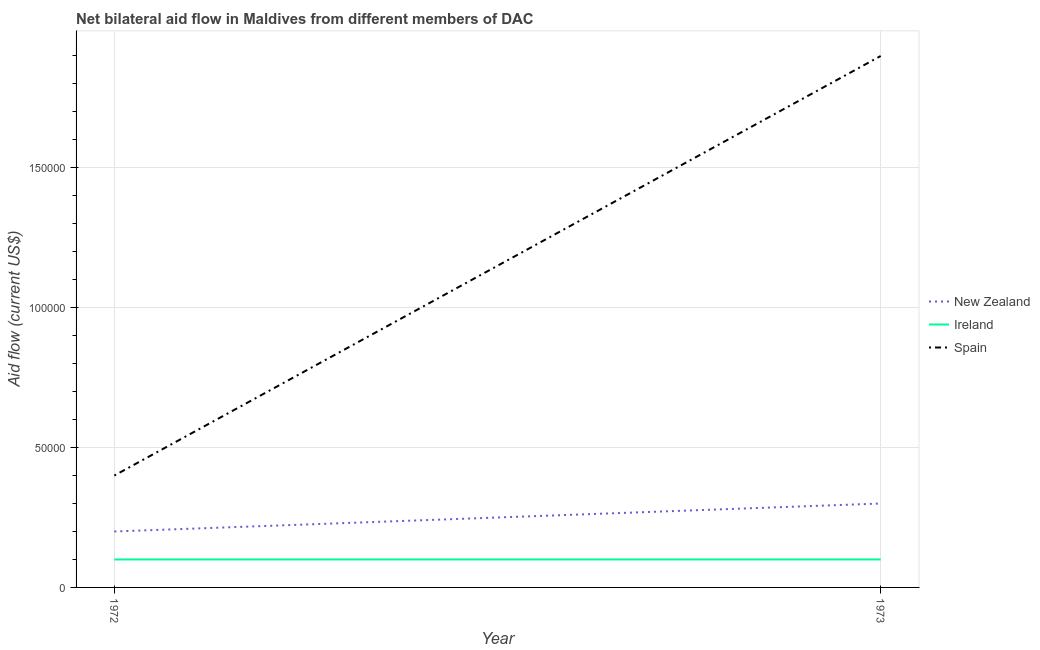What is the amount of aid provided by ireland in 1973?
Ensure brevity in your answer.  10000. Across all years, what is the maximum amount of aid provided by spain?
Offer a terse response. 1.90e+05. Across all years, what is the minimum amount of aid provided by new zealand?
Offer a very short reply. 2.00e+04. In which year was the amount of aid provided by new zealand minimum?
Give a very brief answer. 1972. What is the total amount of aid provided by spain in the graph?
Your response must be concise. 2.30e+05. What is the difference between the amount of aid provided by ireland in 1972 and that in 1973?
Offer a very short reply. 0. What is the difference between the amount of aid provided by spain in 1973 and the amount of aid provided by ireland in 1972?
Offer a very short reply. 1.80e+05. What is the average amount of aid provided by new zealand per year?
Your answer should be compact. 2.50e+04. In the year 1972, what is the difference between the amount of aid provided by new zealand and amount of aid provided by ireland?
Offer a terse response. 10000. In how many years, is the amount of aid provided by new zealand greater than 140000 US$?
Offer a terse response. 0. How many lines are there?
Give a very brief answer. 3. What is the difference between two consecutive major ticks on the Y-axis?
Make the answer very short. 5.00e+04. Does the graph contain grids?
Offer a very short reply. Yes. Where does the legend appear in the graph?
Ensure brevity in your answer.  Center right. What is the title of the graph?
Make the answer very short. Net bilateral aid flow in Maldives from different members of DAC. What is the label or title of the Y-axis?
Make the answer very short. Aid flow (current US$). What is the Aid flow (current US$) of New Zealand in 1972?
Offer a very short reply. 2.00e+04. Across all years, what is the maximum Aid flow (current US$) in Ireland?
Provide a succinct answer. 10000. Across all years, what is the minimum Aid flow (current US$) of New Zealand?
Your answer should be very brief. 2.00e+04. Across all years, what is the minimum Aid flow (current US$) in Spain?
Ensure brevity in your answer.  4.00e+04. What is the total Aid flow (current US$) of Ireland in the graph?
Provide a short and direct response. 2.00e+04. What is the difference between the Aid flow (current US$) of New Zealand in 1972 and that in 1973?
Give a very brief answer. -10000. What is the difference between the Aid flow (current US$) of Ireland in 1972 and that in 1973?
Your answer should be compact. 0. What is the difference between the Aid flow (current US$) in Spain in 1972 and that in 1973?
Ensure brevity in your answer.  -1.50e+05. What is the difference between the Aid flow (current US$) in New Zealand in 1972 and the Aid flow (current US$) in Spain in 1973?
Your response must be concise. -1.70e+05. What is the difference between the Aid flow (current US$) in Ireland in 1972 and the Aid flow (current US$) in Spain in 1973?
Offer a terse response. -1.80e+05. What is the average Aid flow (current US$) in New Zealand per year?
Offer a very short reply. 2.50e+04. What is the average Aid flow (current US$) in Ireland per year?
Offer a very short reply. 10000. What is the average Aid flow (current US$) of Spain per year?
Your answer should be compact. 1.15e+05. In the year 1973, what is the difference between the Aid flow (current US$) in New Zealand and Aid flow (current US$) in Spain?
Provide a short and direct response. -1.60e+05. What is the ratio of the Aid flow (current US$) of Ireland in 1972 to that in 1973?
Provide a short and direct response. 1. What is the ratio of the Aid flow (current US$) of Spain in 1972 to that in 1973?
Make the answer very short. 0.21. What is the difference between the highest and the second highest Aid flow (current US$) of New Zealand?
Your answer should be compact. 10000. What is the difference between the highest and the second highest Aid flow (current US$) of Ireland?
Give a very brief answer. 0. What is the difference between the highest and the lowest Aid flow (current US$) of Ireland?
Ensure brevity in your answer.  0. What is the difference between the highest and the lowest Aid flow (current US$) of Spain?
Give a very brief answer. 1.50e+05. 